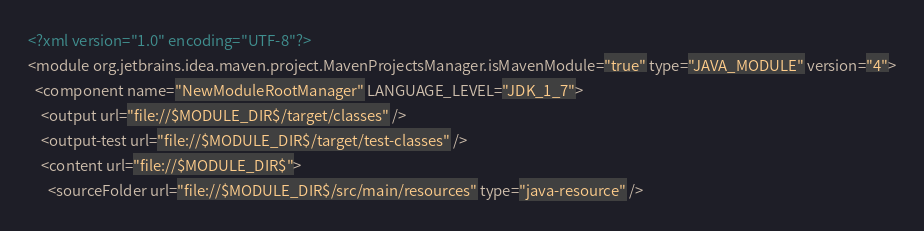<code> <loc_0><loc_0><loc_500><loc_500><_XML_><?xml version="1.0" encoding="UTF-8"?>
<module org.jetbrains.idea.maven.project.MavenProjectsManager.isMavenModule="true" type="JAVA_MODULE" version="4">
  <component name="NewModuleRootManager" LANGUAGE_LEVEL="JDK_1_7">
    <output url="file://$MODULE_DIR$/target/classes" />
    <output-test url="file://$MODULE_DIR$/target/test-classes" />
    <content url="file://$MODULE_DIR$">
      <sourceFolder url="file://$MODULE_DIR$/src/main/resources" type="java-resource" /></code> 